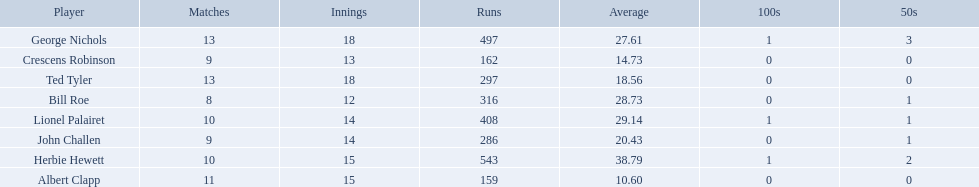Who are the players in somerset county cricket club in 1890? Herbie Hewett, Lionel Palairet, Bill Roe, George Nichols, John Challen, Ted Tyler, Crescens Robinson, Albert Clapp. Who is the only player to play less than 13 innings? Bill Roe. 